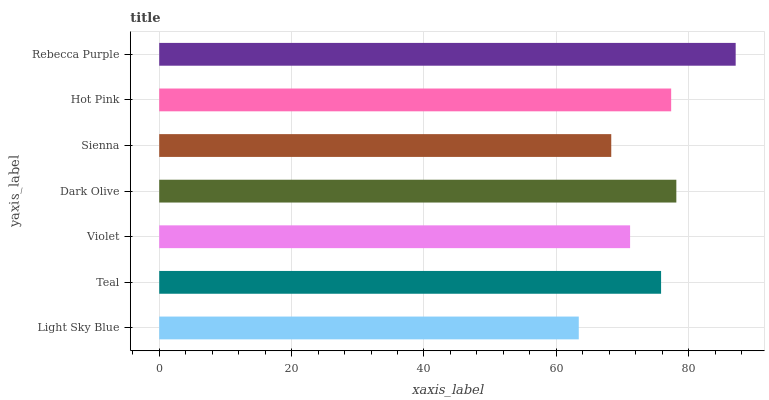Is Light Sky Blue the minimum?
Answer yes or no. Yes. Is Rebecca Purple the maximum?
Answer yes or no. Yes. Is Teal the minimum?
Answer yes or no. No. Is Teal the maximum?
Answer yes or no. No. Is Teal greater than Light Sky Blue?
Answer yes or no. Yes. Is Light Sky Blue less than Teal?
Answer yes or no. Yes. Is Light Sky Blue greater than Teal?
Answer yes or no. No. Is Teal less than Light Sky Blue?
Answer yes or no. No. Is Teal the high median?
Answer yes or no. Yes. Is Teal the low median?
Answer yes or no. Yes. Is Rebecca Purple the high median?
Answer yes or no. No. Is Rebecca Purple the low median?
Answer yes or no. No. 